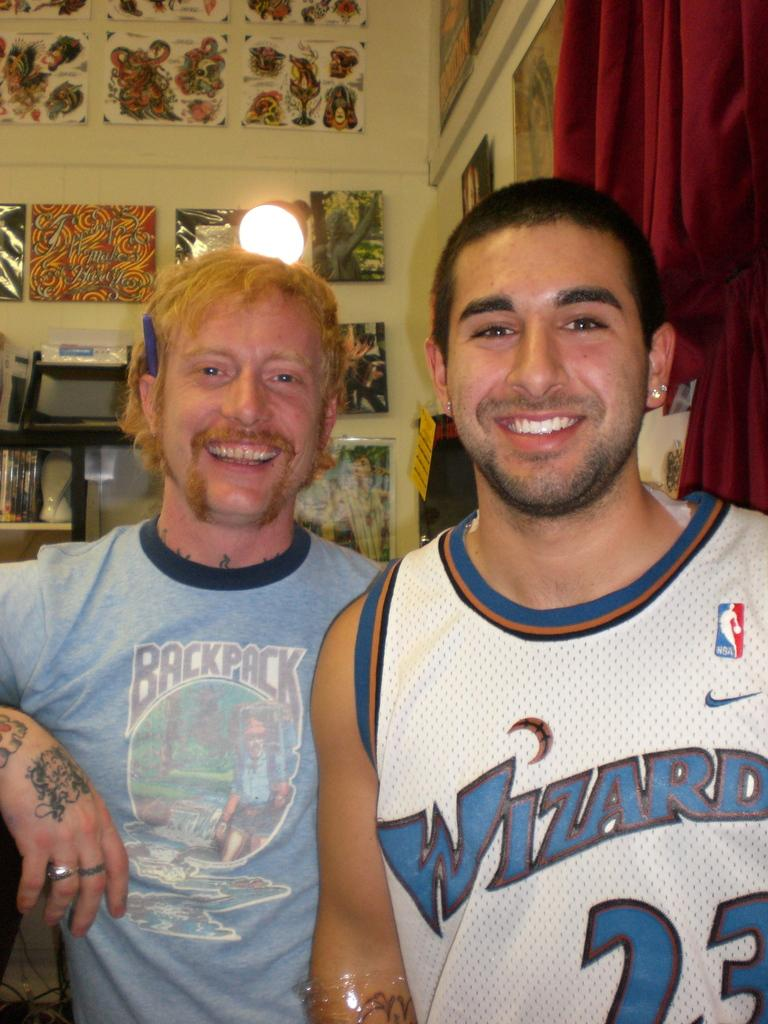<image>
Share a concise interpretation of the image provided. Two men standing together, one with Wizard 23 on his shirt. 